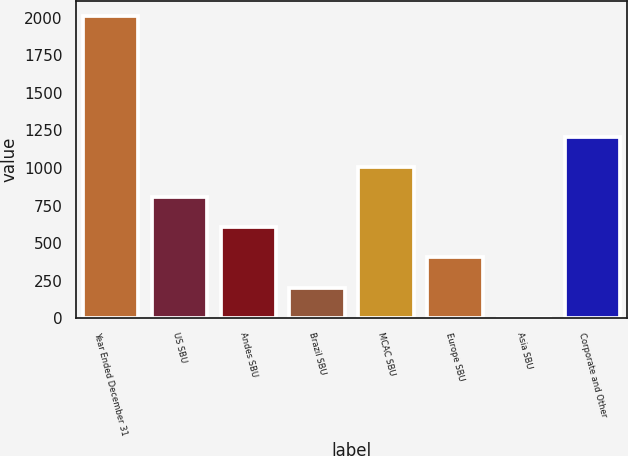Convert chart to OTSL. <chart><loc_0><loc_0><loc_500><loc_500><bar_chart><fcel>Year Ended December 31<fcel>US SBU<fcel>Andes SBU<fcel>Brazil SBU<fcel>MCAC SBU<fcel>Europe SBU<fcel>Asia SBU<fcel>Corporate and Other<nl><fcel>2014<fcel>806.8<fcel>605.6<fcel>203.2<fcel>1008<fcel>404.4<fcel>2<fcel>1209.2<nl></chart> 